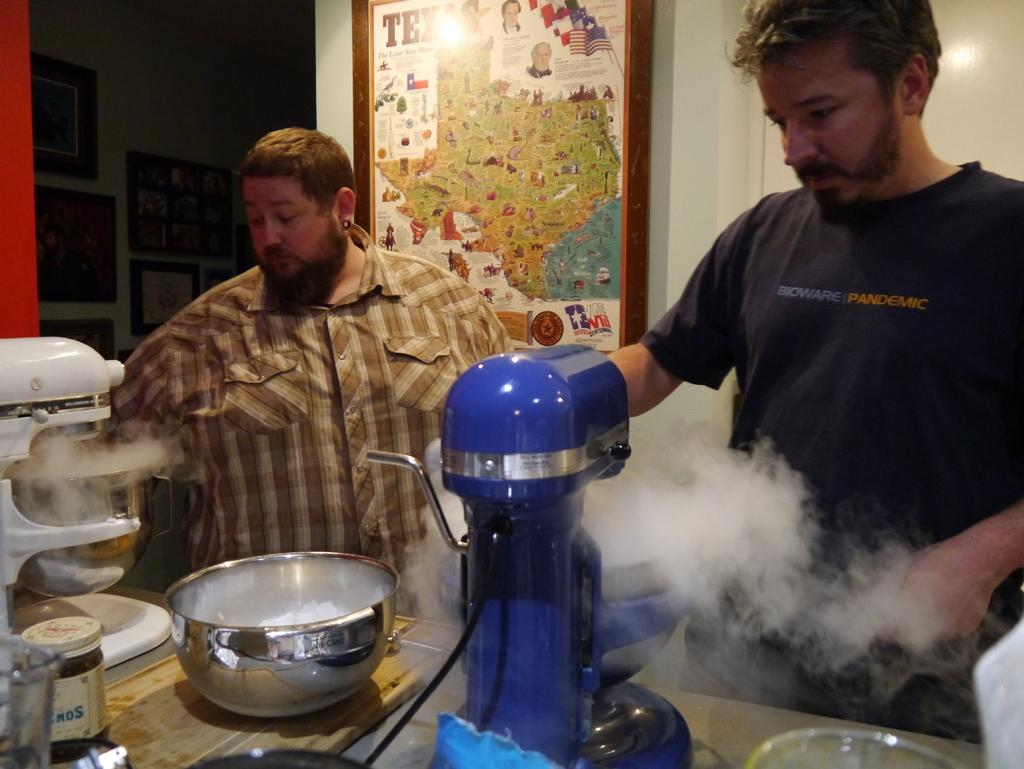<image>
Summarize the visual content of the image. A man working with a KitchenAid mixer wears a Bioware Pandemic t-shirt. 